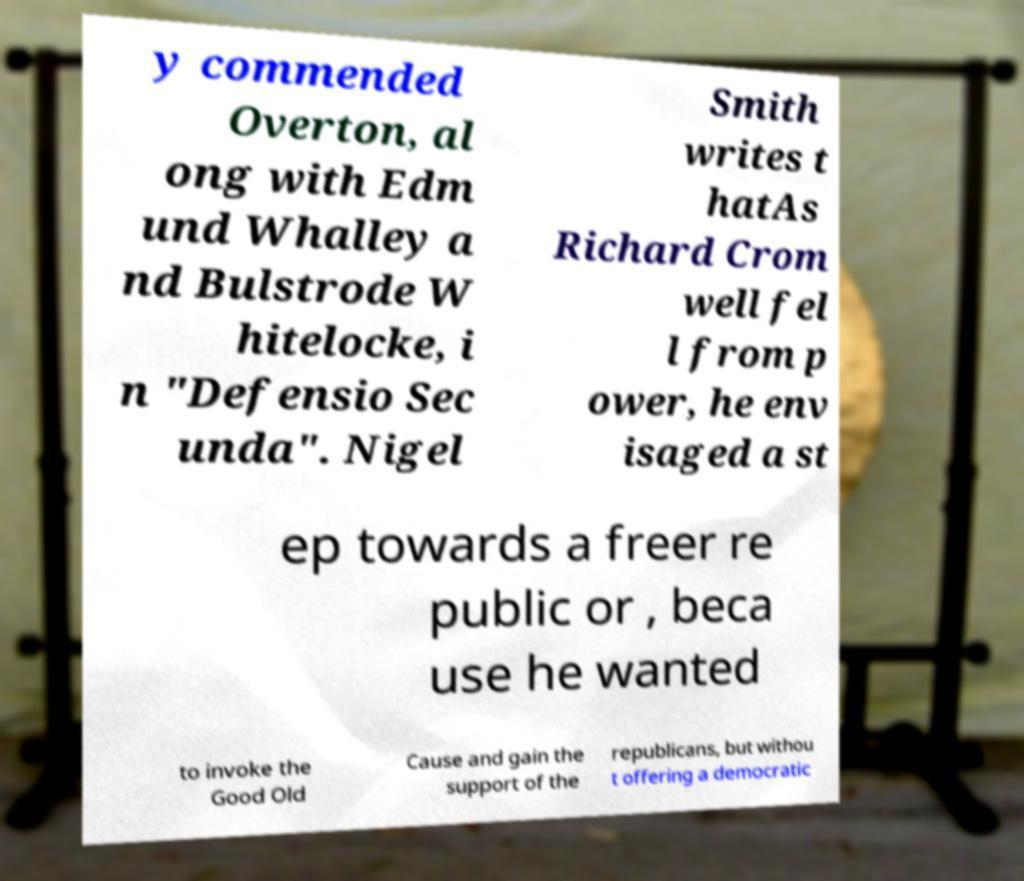Can you read and provide the text displayed in the image?This photo seems to have some interesting text. Can you extract and type it out for me? y commended Overton, al ong with Edm und Whalley a nd Bulstrode W hitelocke, i n "Defensio Sec unda". Nigel Smith writes t hatAs Richard Crom well fel l from p ower, he env isaged a st ep towards a freer re public or , beca use he wanted to invoke the Good Old Cause and gain the support of the republicans, but withou t offering a democratic 